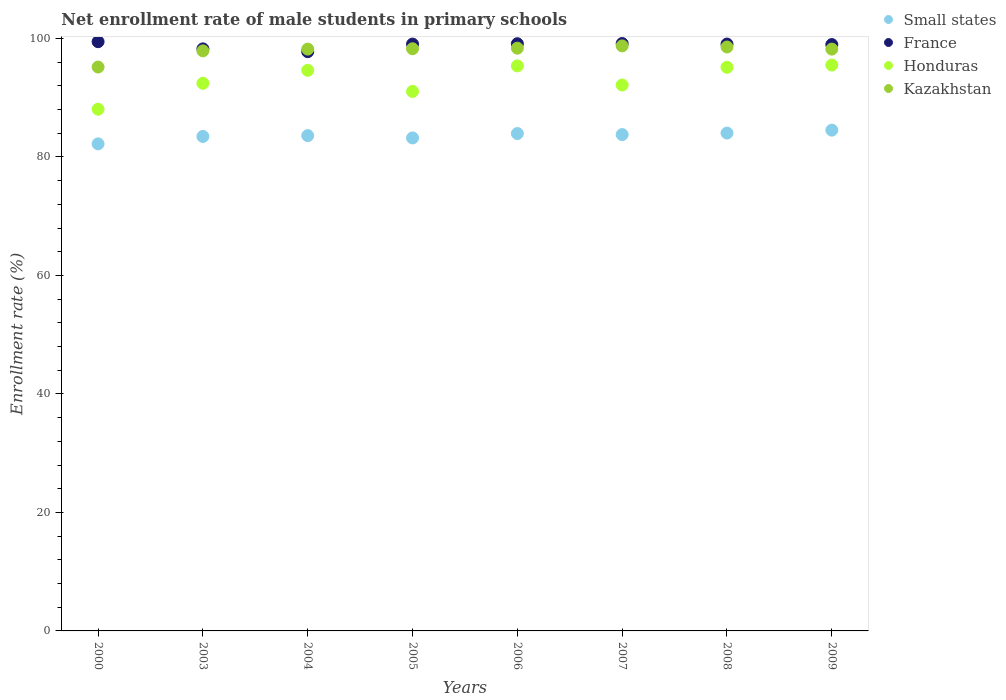Is the number of dotlines equal to the number of legend labels?
Provide a short and direct response. Yes. What is the net enrollment rate of male students in primary schools in Small states in 2008?
Your answer should be very brief. 84.03. Across all years, what is the maximum net enrollment rate of male students in primary schools in Kazakhstan?
Your answer should be compact. 98.74. Across all years, what is the minimum net enrollment rate of male students in primary schools in France?
Provide a short and direct response. 97.77. In which year was the net enrollment rate of male students in primary schools in Honduras maximum?
Make the answer very short. 2009. In which year was the net enrollment rate of male students in primary schools in Small states minimum?
Provide a succinct answer. 2000. What is the total net enrollment rate of male students in primary schools in France in the graph?
Your answer should be compact. 790.77. What is the difference between the net enrollment rate of male students in primary schools in Kazakhstan in 2000 and that in 2009?
Give a very brief answer. -3.03. What is the difference between the net enrollment rate of male students in primary schools in France in 2004 and the net enrollment rate of male students in primary schools in Kazakhstan in 2003?
Give a very brief answer. -0.14. What is the average net enrollment rate of male students in primary schools in Kazakhstan per year?
Provide a short and direct response. 97.92. In the year 2000, what is the difference between the net enrollment rate of male students in primary schools in Small states and net enrollment rate of male students in primary schools in Honduras?
Your response must be concise. -5.85. What is the ratio of the net enrollment rate of male students in primary schools in Small states in 2003 to that in 2006?
Keep it short and to the point. 0.99. Is the difference between the net enrollment rate of male students in primary schools in Small states in 2003 and 2006 greater than the difference between the net enrollment rate of male students in primary schools in Honduras in 2003 and 2006?
Ensure brevity in your answer.  Yes. What is the difference between the highest and the second highest net enrollment rate of male students in primary schools in Small states?
Provide a short and direct response. 0.49. What is the difference between the highest and the lowest net enrollment rate of male students in primary schools in Kazakhstan?
Your answer should be compact. 3.57. In how many years, is the net enrollment rate of male students in primary schools in Small states greater than the average net enrollment rate of male students in primary schools in Small states taken over all years?
Your answer should be very brief. 5. Is the sum of the net enrollment rate of male students in primary schools in Kazakhstan in 2004 and 2005 greater than the maximum net enrollment rate of male students in primary schools in Honduras across all years?
Give a very brief answer. Yes. Does the net enrollment rate of male students in primary schools in Kazakhstan monotonically increase over the years?
Ensure brevity in your answer.  No. Is the net enrollment rate of male students in primary schools in Small states strictly less than the net enrollment rate of male students in primary schools in Honduras over the years?
Provide a short and direct response. Yes. How many dotlines are there?
Keep it short and to the point. 4. How many years are there in the graph?
Make the answer very short. 8. What is the difference between two consecutive major ticks on the Y-axis?
Make the answer very short. 20. Are the values on the major ticks of Y-axis written in scientific E-notation?
Your response must be concise. No. Does the graph contain any zero values?
Your response must be concise. No. What is the title of the graph?
Your response must be concise. Net enrollment rate of male students in primary schools. Does "Kiribati" appear as one of the legend labels in the graph?
Provide a short and direct response. No. What is the label or title of the Y-axis?
Keep it short and to the point. Enrollment rate (%). What is the Enrollment rate (%) of Small states in 2000?
Offer a terse response. 82.21. What is the Enrollment rate (%) of France in 2000?
Offer a terse response. 99.45. What is the Enrollment rate (%) of Honduras in 2000?
Your answer should be very brief. 88.06. What is the Enrollment rate (%) of Kazakhstan in 2000?
Your answer should be compact. 95.17. What is the Enrollment rate (%) in Small states in 2003?
Your response must be concise. 83.46. What is the Enrollment rate (%) in France in 2003?
Offer a terse response. 98.24. What is the Enrollment rate (%) in Honduras in 2003?
Offer a terse response. 92.43. What is the Enrollment rate (%) of Kazakhstan in 2003?
Provide a short and direct response. 97.9. What is the Enrollment rate (%) in Small states in 2004?
Provide a succinct answer. 83.6. What is the Enrollment rate (%) of France in 2004?
Your response must be concise. 97.77. What is the Enrollment rate (%) in Honduras in 2004?
Offer a very short reply. 94.62. What is the Enrollment rate (%) of Kazakhstan in 2004?
Make the answer very short. 98.2. What is the Enrollment rate (%) of Small states in 2005?
Offer a terse response. 83.21. What is the Enrollment rate (%) in France in 2005?
Your response must be concise. 99.05. What is the Enrollment rate (%) of Honduras in 2005?
Give a very brief answer. 91.06. What is the Enrollment rate (%) of Kazakhstan in 2005?
Your answer should be compact. 98.26. What is the Enrollment rate (%) of Small states in 2006?
Your response must be concise. 83.95. What is the Enrollment rate (%) in France in 2006?
Provide a succinct answer. 99.11. What is the Enrollment rate (%) in Honduras in 2006?
Provide a short and direct response. 95.37. What is the Enrollment rate (%) of Kazakhstan in 2006?
Keep it short and to the point. 98.36. What is the Enrollment rate (%) of Small states in 2007?
Make the answer very short. 83.77. What is the Enrollment rate (%) of France in 2007?
Offer a very short reply. 99.14. What is the Enrollment rate (%) of Honduras in 2007?
Your response must be concise. 92.14. What is the Enrollment rate (%) of Kazakhstan in 2007?
Offer a very short reply. 98.74. What is the Enrollment rate (%) of Small states in 2008?
Make the answer very short. 84.03. What is the Enrollment rate (%) of France in 2008?
Your response must be concise. 99.05. What is the Enrollment rate (%) of Honduras in 2008?
Make the answer very short. 95.13. What is the Enrollment rate (%) in Kazakhstan in 2008?
Provide a succinct answer. 98.56. What is the Enrollment rate (%) of Small states in 2009?
Make the answer very short. 84.52. What is the Enrollment rate (%) of France in 2009?
Give a very brief answer. 98.97. What is the Enrollment rate (%) in Honduras in 2009?
Give a very brief answer. 95.51. What is the Enrollment rate (%) of Kazakhstan in 2009?
Offer a very short reply. 98.2. Across all years, what is the maximum Enrollment rate (%) of Small states?
Offer a very short reply. 84.52. Across all years, what is the maximum Enrollment rate (%) in France?
Keep it short and to the point. 99.45. Across all years, what is the maximum Enrollment rate (%) in Honduras?
Provide a short and direct response. 95.51. Across all years, what is the maximum Enrollment rate (%) of Kazakhstan?
Make the answer very short. 98.74. Across all years, what is the minimum Enrollment rate (%) of Small states?
Give a very brief answer. 82.21. Across all years, what is the minimum Enrollment rate (%) of France?
Offer a very short reply. 97.77. Across all years, what is the minimum Enrollment rate (%) in Honduras?
Provide a succinct answer. 88.06. Across all years, what is the minimum Enrollment rate (%) in Kazakhstan?
Make the answer very short. 95.17. What is the total Enrollment rate (%) of Small states in the graph?
Offer a terse response. 668.75. What is the total Enrollment rate (%) of France in the graph?
Make the answer very short. 790.77. What is the total Enrollment rate (%) in Honduras in the graph?
Make the answer very short. 744.32. What is the total Enrollment rate (%) of Kazakhstan in the graph?
Offer a terse response. 783.4. What is the difference between the Enrollment rate (%) of Small states in 2000 and that in 2003?
Give a very brief answer. -1.25. What is the difference between the Enrollment rate (%) in France in 2000 and that in 2003?
Your answer should be compact. 1.21. What is the difference between the Enrollment rate (%) in Honduras in 2000 and that in 2003?
Provide a succinct answer. -4.37. What is the difference between the Enrollment rate (%) of Kazakhstan in 2000 and that in 2003?
Give a very brief answer. -2.73. What is the difference between the Enrollment rate (%) of Small states in 2000 and that in 2004?
Provide a short and direct response. -1.39. What is the difference between the Enrollment rate (%) in France in 2000 and that in 2004?
Your answer should be very brief. 1.69. What is the difference between the Enrollment rate (%) in Honduras in 2000 and that in 2004?
Make the answer very short. -6.57. What is the difference between the Enrollment rate (%) of Kazakhstan in 2000 and that in 2004?
Offer a very short reply. -3.03. What is the difference between the Enrollment rate (%) of Small states in 2000 and that in 2005?
Your answer should be very brief. -1.01. What is the difference between the Enrollment rate (%) in France in 2000 and that in 2005?
Provide a succinct answer. 0.41. What is the difference between the Enrollment rate (%) of Honduras in 2000 and that in 2005?
Your response must be concise. -3. What is the difference between the Enrollment rate (%) of Kazakhstan in 2000 and that in 2005?
Give a very brief answer. -3.09. What is the difference between the Enrollment rate (%) in Small states in 2000 and that in 2006?
Offer a terse response. -1.75. What is the difference between the Enrollment rate (%) in France in 2000 and that in 2006?
Provide a succinct answer. 0.34. What is the difference between the Enrollment rate (%) in Honduras in 2000 and that in 2006?
Provide a short and direct response. -7.31. What is the difference between the Enrollment rate (%) in Kazakhstan in 2000 and that in 2006?
Your response must be concise. -3.19. What is the difference between the Enrollment rate (%) of Small states in 2000 and that in 2007?
Your answer should be compact. -1.57. What is the difference between the Enrollment rate (%) in France in 2000 and that in 2007?
Make the answer very short. 0.31. What is the difference between the Enrollment rate (%) of Honduras in 2000 and that in 2007?
Your answer should be very brief. -4.08. What is the difference between the Enrollment rate (%) of Kazakhstan in 2000 and that in 2007?
Make the answer very short. -3.57. What is the difference between the Enrollment rate (%) in Small states in 2000 and that in 2008?
Keep it short and to the point. -1.82. What is the difference between the Enrollment rate (%) in France in 2000 and that in 2008?
Ensure brevity in your answer.  0.4. What is the difference between the Enrollment rate (%) of Honduras in 2000 and that in 2008?
Your answer should be compact. -7.07. What is the difference between the Enrollment rate (%) in Kazakhstan in 2000 and that in 2008?
Your response must be concise. -3.39. What is the difference between the Enrollment rate (%) in Small states in 2000 and that in 2009?
Provide a succinct answer. -2.32. What is the difference between the Enrollment rate (%) of France in 2000 and that in 2009?
Ensure brevity in your answer.  0.49. What is the difference between the Enrollment rate (%) of Honduras in 2000 and that in 2009?
Your answer should be compact. -7.45. What is the difference between the Enrollment rate (%) of Kazakhstan in 2000 and that in 2009?
Your answer should be very brief. -3.03. What is the difference between the Enrollment rate (%) in Small states in 2003 and that in 2004?
Ensure brevity in your answer.  -0.14. What is the difference between the Enrollment rate (%) of France in 2003 and that in 2004?
Provide a short and direct response. 0.48. What is the difference between the Enrollment rate (%) of Honduras in 2003 and that in 2004?
Keep it short and to the point. -2.19. What is the difference between the Enrollment rate (%) of Kazakhstan in 2003 and that in 2004?
Your answer should be compact. -0.3. What is the difference between the Enrollment rate (%) of Small states in 2003 and that in 2005?
Provide a succinct answer. 0.25. What is the difference between the Enrollment rate (%) in France in 2003 and that in 2005?
Give a very brief answer. -0.8. What is the difference between the Enrollment rate (%) in Honduras in 2003 and that in 2005?
Offer a very short reply. 1.37. What is the difference between the Enrollment rate (%) in Kazakhstan in 2003 and that in 2005?
Provide a succinct answer. -0.36. What is the difference between the Enrollment rate (%) of Small states in 2003 and that in 2006?
Keep it short and to the point. -0.49. What is the difference between the Enrollment rate (%) in France in 2003 and that in 2006?
Ensure brevity in your answer.  -0.87. What is the difference between the Enrollment rate (%) of Honduras in 2003 and that in 2006?
Offer a very short reply. -2.94. What is the difference between the Enrollment rate (%) in Kazakhstan in 2003 and that in 2006?
Give a very brief answer. -0.45. What is the difference between the Enrollment rate (%) of Small states in 2003 and that in 2007?
Provide a short and direct response. -0.32. What is the difference between the Enrollment rate (%) of France in 2003 and that in 2007?
Your response must be concise. -0.9. What is the difference between the Enrollment rate (%) in Honduras in 2003 and that in 2007?
Keep it short and to the point. 0.29. What is the difference between the Enrollment rate (%) of Kazakhstan in 2003 and that in 2007?
Offer a terse response. -0.84. What is the difference between the Enrollment rate (%) in Small states in 2003 and that in 2008?
Your answer should be very brief. -0.57. What is the difference between the Enrollment rate (%) in France in 2003 and that in 2008?
Offer a terse response. -0.81. What is the difference between the Enrollment rate (%) of Honduras in 2003 and that in 2008?
Offer a very short reply. -2.7. What is the difference between the Enrollment rate (%) in Kazakhstan in 2003 and that in 2008?
Offer a very short reply. -0.65. What is the difference between the Enrollment rate (%) in Small states in 2003 and that in 2009?
Offer a very short reply. -1.06. What is the difference between the Enrollment rate (%) in France in 2003 and that in 2009?
Provide a short and direct response. -0.73. What is the difference between the Enrollment rate (%) in Honduras in 2003 and that in 2009?
Make the answer very short. -3.08. What is the difference between the Enrollment rate (%) in Kazakhstan in 2003 and that in 2009?
Give a very brief answer. -0.29. What is the difference between the Enrollment rate (%) of Small states in 2004 and that in 2005?
Offer a very short reply. 0.39. What is the difference between the Enrollment rate (%) in France in 2004 and that in 2005?
Your answer should be compact. -1.28. What is the difference between the Enrollment rate (%) in Honduras in 2004 and that in 2005?
Ensure brevity in your answer.  3.56. What is the difference between the Enrollment rate (%) of Kazakhstan in 2004 and that in 2005?
Offer a terse response. -0.06. What is the difference between the Enrollment rate (%) of Small states in 2004 and that in 2006?
Your answer should be compact. -0.35. What is the difference between the Enrollment rate (%) in France in 2004 and that in 2006?
Your response must be concise. -1.34. What is the difference between the Enrollment rate (%) of Honduras in 2004 and that in 2006?
Keep it short and to the point. -0.74. What is the difference between the Enrollment rate (%) in Kazakhstan in 2004 and that in 2006?
Provide a succinct answer. -0.16. What is the difference between the Enrollment rate (%) in Small states in 2004 and that in 2007?
Provide a succinct answer. -0.17. What is the difference between the Enrollment rate (%) of France in 2004 and that in 2007?
Your answer should be compact. -1.37. What is the difference between the Enrollment rate (%) of Honduras in 2004 and that in 2007?
Your response must be concise. 2.48. What is the difference between the Enrollment rate (%) of Kazakhstan in 2004 and that in 2007?
Make the answer very short. -0.54. What is the difference between the Enrollment rate (%) in Small states in 2004 and that in 2008?
Give a very brief answer. -0.43. What is the difference between the Enrollment rate (%) in France in 2004 and that in 2008?
Offer a terse response. -1.28. What is the difference between the Enrollment rate (%) of Honduras in 2004 and that in 2008?
Your answer should be compact. -0.51. What is the difference between the Enrollment rate (%) in Kazakhstan in 2004 and that in 2008?
Give a very brief answer. -0.36. What is the difference between the Enrollment rate (%) of Small states in 2004 and that in 2009?
Make the answer very short. -0.92. What is the difference between the Enrollment rate (%) in France in 2004 and that in 2009?
Your answer should be very brief. -1.2. What is the difference between the Enrollment rate (%) of Honduras in 2004 and that in 2009?
Offer a terse response. -0.89. What is the difference between the Enrollment rate (%) of Kazakhstan in 2004 and that in 2009?
Keep it short and to the point. 0. What is the difference between the Enrollment rate (%) of Small states in 2005 and that in 2006?
Offer a terse response. -0.74. What is the difference between the Enrollment rate (%) of France in 2005 and that in 2006?
Provide a succinct answer. -0.06. What is the difference between the Enrollment rate (%) in Honduras in 2005 and that in 2006?
Offer a very short reply. -4.31. What is the difference between the Enrollment rate (%) in Kazakhstan in 2005 and that in 2006?
Your answer should be compact. -0.1. What is the difference between the Enrollment rate (%) in Small states in 2005 and that in 2007?
Offer a terse response. -0.56. What is the difference between the Enrollment rate (%) in France in 2005 and that in 2007?
Provide a succinct answer. -0.09. What is the difference between the Enrollment rate (%) of Honduras in 2005 and that in 2007?
Your response must be concise. -1.08. What is the difference between the Enrollment rate (%) of Kazakhstan in 2005 and that in 2007?
Keep it short and to the point. -0.48. What is the difference between the Enrollment rate (%) of Small states in 2005 and that in 2008?
Offer a very short reply. -0.82. What is the difference between the Enrollment rate (%) in France in 2005 and that in 2008?
Offer a very short reply. -0. What is the difference between the Enrollment rate (%) in Honduras in 2005 and that in 2008?
Offer a terse response. -4.07. What is the difference between the Enrollment rate (%) in Kazakhstan in 2005 and that in 2008?
Ensure brevity in your answer.  -0.3. What is the difference between the Enrollment rate (%) of Small states in 2005 and that in 2009?
Give a very brief answer. -1.31. What is the difference between the Enrollment rate (%) in France in 2005 and that in 2009?
Ensure brevity in your answer.  0.08. What is the difference between the Enrollment rate (%) of Honduras in 2005 and that in 2009?
Keep it short and to the point. -4.45. What is the difference between the Enrollment rate (%) in Kazakhstan in 2005 and that in 2009?
Offer a terse response. 0.06. What is the difference between the Enrollment rate (%) in Small states in 2006 and that in 2007?
Your answer should be very brief. 0.18. What is the difference between the Enrollment rate (%) of France in 2006 and that in 2007?
Provide a short and direct response. -0.03. What is the difference between the Enrollment rate (%) of Honduras in 2006 and that in 2007?
Provide a succinct answer. 3.22. What is the difference between the Enrollment rate (%) of Kazakhstan in 2006 and that in 2007?
Your answer should be compact. -0.38. What is the difference between the Enrollment rate (%) of Small states in 2006 and that in 2008?
Keep it short and to the point. -0.08. What is the difference between the Enrollment rate (%) of France in 2006 and that in 2008?
Offer a terse response. 0.06. What is the difference between the Enrollment rate (%) in Honduras in 2006 and that in 2008?
Make the answer very short. 0.24. What is the difference between the Enrollment rate (%) in Kazakhstan in 2006 and that in 2008?
Make the answer very short. -0.2. What is the difference between the Enrollment rate (%) in Small states in 2006 and that in 2009?
Your answer should be compact. -0.57. What is the difference between the Enrollment rate (%) in France in 2006 and that in 2009?
Offer a very short reply. 0.14. What is the difference between the Enrollment rate (%) of Honduras in 2006 and that in 2009?
Your answer should be compact. -0.15. What is the difference between the Enrollment rate (%) of Kazakhstan in 2006 and that in 2009?
Provide a short and direct response. 0.16. What is the difference between the Enrollment rate (%) of Small states in 2007 and that in 2008?
Your response must be concise. -0.25. What is the difference between the Enrollment rate (%) of France in 2007 and that in 2008?
Give a very brief answer. 0.09. What is the difference between the Enrollment rate (%) in Honduras in 2007 and that in 2008?
Your answer should be compact. -2.99. What is the difference between the Enrollment rate (%) of Kazakhstan in 2007 and that in 2008?
Offer a very short reply. 0.19. What is the difference between the Enrollment rate (%) in Small states in 2007 and that in 2009?
Offer a very short reply. -0.75. What is the difference between the Enrollment rate (%) of France in 2007 and that in 2009?
Your response must be concise. 0.17. What is the difference between the Enrollment rate (%) of Honduras in 2007 and that in 2009?
Your response must be concise. -3.37. What is the difference between the Enrollment rate (%) of Kazakhstan in 2007 and that in 2009?
Ensure brevity in your answer.  0.54. What is the difference between the Enrollment rate (%) of Small states in 2008 and that in 2009?
Your response must be concise. -0.49. What is the difference between the Enrollment rate (%) in France in 2008 and that in 2009?
Your answer should be compact. 0.08. What is the difference between the Enrollment rate (%) in Honduras in 2008 and that in 2009?
Your answer should be compact. -0.38. What is the difference between the Enrollment rate (%) in Kazakhstan in 2008 and that in 2009?
Your answer should be compact. 0.36. What is the difference between the Enrollment rate (%) in Small states in 2000 and the Enrollment rate (%) in France in 2003?
Your answer should be compact. -16.04. What is the difference between the Enrollment rate (%) of Small states in 2000 and the Enrollment rate (%) of Honduras in 2003?
Provide a short and direct response. -10.22. What is the difference between the Enrollment rate (%) of Small states in 2000 and the Enrollment rate (%) of Kazakhstan in 2003?
Offer a terse response. -15.7. What is the difference between the Enrollment rate (%) in France in 2000 and the Enrollment rate (%) in Honduras in 2003?
Ensure brevity in your answer.  7.03. What is the difference between the Enrollment rate (%) of France in 2000 and the Enrollment rate (%) of Kazakhstan in 2003?
Ensure brevity in your answer.  1.55. What is the difference between the Enrollment rate (%) of Honduras in 2000 and the Enrollment rate (%) of Kazakhstan in 2003?
Provide a short and direct response. -9.85. What is the difference between the Enrollment rate (%) of Small states in 2000 and the Enrollment rate (%) of France in 2004?
Make the answer very short. -15.56. What is the difference between the Enrollment rate (%) in Small states in 2000 and the Enrollment rate (%) in Honduras in 2004?
Make the answer very short. -12.42. What is the difference between the Enrollment rate (%) of Small states in 2000 and the Enrollment rate (%) of Kazakhstan in 2004?
Offer a very short reply. -16. What is the difference between the Enrollment rate (%) of France in 2000 and the Enrollment rate (%) of Honduras in 2004?
Your answer should be compact. 4.83. What is the difference between the Enrollment rate (%) in France in 2000 and the Enrollment rate (%) in Kazakhstan in 2004?
Your response must be concise. 1.25. What is the difference between the Enrollment rate (%) of Honduras in 2000 and the Enrollment rate (%) of Kazakhstan in 2004?
Make the answer very short. -10.14. What is the difference between the Enrollment rate (%) in Small states in 2000 and the Enrollment rate (%) in France in 2005?
Offer a very short reply. -16.84. What is the difference between the Enrollment rate (%) in Small states in 2000 and the Enrollment rate (%) in Honduras in 2005?
Provide a succinct answer. -8.85. What is the difference between the Enrollment rate (%) in Small states in 2000 and the Enrollment rate (%) in Kazakhstan in 2005?
Give a very brief answer. -16.06. What is the difference between the Enrollment rate (%) in France in 2000 and the Enrollment rate (%) in Honduras in 2005?
Your answer should be very brief. 8.39. What is the difference between the Enrollment rate (%) of France in 2000 and the Enrollment rate (%) of Kazakhstan in 2005?
Make the answer very short. 1.19. What is the difference between the Enrollment rate (%) of Honduras in 2000 and the Enrollment rate (%) of Kazakhstan in 2005?
Offer a very short reply. -10.2. What is the difference between the Enrollment rate (%) of Small states in 2000 and the Enrollment rate (%) of France in 2006?
Your response must be concise. -16.9. What is the difference between the Enrollment rate (%) of Small states in 2000 and the Enrollment rate (%) of Honduras in 2006?
Offer a terse response. -13.16. What is the difference between the Enrollment rate (%) in Small states in 2000 and the Enrollment rate (%) in Kazakhstan in 2006?
Give a very brief answer. -16.15. What is the difference between the Enrollment rate (%) in France in 2000 and the Enrollment rate (%) in Honduras in 2006?
Provide a succinct answer. 4.09. What is the difference between the Enrollment rate (%) of France in 2000 and the Enrollment rate (%) of Kazakhstan in 2006?
Make the answer very short. 1.09. What is the difference between the Enrollment rate (%) of Honduras in 2000 and the Enrollment rate (%) of Kazakhstan in 2006?
Your response must be concise. -10.3. What is the difference between the Enrollment rate (%) in Small states in 2000 and the Enrollment rate (%) in France in 2007?
Make the answer very short. -16.93. What is the difference between the Enrollment rate (%) in Small states in 2000 and the Enrollment rate (%) in Honduras in 2007?
Give a very brief answer. -9.94. What is the difference between the Enrollment rate (%) in Small states in 2000 and the Enrollment rate (%) in Kazakhstan in 2007?
Provide a succinct answer. -16.54. What is the difference between the Enrollment rate (%) of France in 2000 and the Enrollment rate (%) of Honduras in 2007?
Give a very brief answer. 7.31. What is the difference between the Enrollment rate (%) in France in 2000 and the Enrollment rate (%) in Kazakhstan in 2007?
Offer a terse response. 0.71. What is the difference between the Enrollment rate (%) in Honduras in 2000 and the Enrollment rate (%) in Kazakhstan in 2007?
Offer a terse response. -10.69. What is the difference between the Enrollment rate (%) in Small states in 2000 and the Enrollment rate (%) in France in 2008?
Offer a terse response. -16.85. What is the difference between the Enrollment rate (%) of Small states in 2000 and the Enrollment rate (%) of Honduras in 2008?
Give a very brief answer. -12.93. What is the difference between the Enrollment rate (%) of Small states in 2000 and the Enrollment rate (%) of Kazakhstan in 2008?
Provide a succinct answer. -16.35. What is the difference between the Enrollment rate (%) in France in 2000 and the Enrollment rate (%) in Honduras in 2008?
Provide a short and direct response. 4.32. What is the difference between the Enrollment rate (%) of France in 2000 and the Enrollment rate (%) of Kazakhstan in 2008?
Provide a short and direct response. 0.9. What is the difference between the Enrollment rate (%) in Honduras in 2000 and the Enrollment rate (%) in Kazakhstan in 2008?
Make the answer very short. -10.5. What is the difference between the Enrollment rate (%) in Small states in 2000 and the Enrollment rate (%) in France in 2009?
Your response must be concise. -16.76. What is the difference between the Enrollment rate (%) in Small states in 2000 and the Enrollment rate (%) in Honduras in 2009?
Your answer should be very brief. -13.31. What is the difference between the Enrollment rate (%) in Small states in 2000 and the Enrollment rate (%) in Kazakhstan in 2009?
Provide a succinct answer. -15.99. What is the difference between the Enrollment rate (%) of France in 2000 and the Enrollment rate (%) of Honduras in 2009?
Make the answer very short. 3.94. What is the difference between the Enrollment rate (%) in France in 2000 and the Enrollment rate (%) in Kazakhstan in 2009?
Your response must be concise. 1.25. What is the difference between the Enrollment rate (%) of Honduras in 2000 and the Enrollment rate (%) of Kazakhstan in 2009?
Give a very brief answer. -10.14. What is the difference between the Enrollment rate (%) of Small states in 2003 and the Enrollment rate (%) of France in 2004?
Provide a short and direct response. -14.31. What is the difference between the Enrollment rate (%) of Small states in 2003 and the Enrollment rate (%) of Honduras in 2004?
Offer a very short reply. -11.16. What is the difference between the Enrollment rate (%) of Small states in 2003 and the Enrollment rate (%) of Kazakhstan in 2004?
Your response must be concise. -14.74. What is the difference between the Enrollment rate (%) of France in 2003 and the Enrollment rate (%) of Honduras in 2004?
Offer a very short reply. 3.62. What is the difference between the Enrollment rate (%) of France in 2003 and the Enrollment rate (%) of Kazakhstan in 2004?
Offer a very short reply. 0.04. What is the difference between the Enrollment rate (%) in Honduras in 2003 and the Enrollment rate (%) in Kazakhstan in 2004?
Offer a very short reply. -5.77. What is the difference between the Enrollment rate (%) in Small states in 2003 and the Enrollment rate (%) in France in 2005?
Offer a very short reply. -15.59. What is the difference between the Enrollment rate (%) in Small states in 2003 and the Enrollment rate (%) in Honduras in 2005?
Provide a succinct answer. -7.6. What is the difference between the Enrollment rate (%) in Small states in 2003 and the Enrollment rate (%) in Kazakhstan in 2005?
Give a very brief answer. -14.8. What is the difference between the Enrollment rate (%) in France in 2003 and the Enrollment rate (%) in Honduras in 2005?
Offer a very short reply. 7.18. What is the difference between the Enrollment rate (%) of France in 2003 and the Enrollment rate (%) of Kazakhstan in 2005?
Keep it short and to the point. -0.02. What is the difference between the Enrollment rate (%) in Honduras in 2003 and the Enrollment rate (%) in Kazakhstan in 2005?
Give a very brief answer. -5.83. What is the difference between the Enrollment rate (%) of Small states in 2003 and the Enrollment rate (%) of France in 2006?
Your response must be concise. -15.65. What is the difference between the Enrollment rate (%) in Small states in 2003 and the Enrollment rate (%) in Honduras in 2006?
Offer a terse response. -11.91. What is the difference between the Enrollment rate (%) of Small states in 2003 and the Enrollment rate (%) of Kazakhstan in 2006?
Your response must be concise. -14.9. What is the difference between the Enrollment rate (%) in France in 2003 and the Enrollment rate (%) in Honduras in 2006?
Provide a short and direct response. 2.88. What is the difference between the Enrollment rate (%) of France in 2003 and the Enrollment rate (%) of Kazakhstan in 2006?
Offer a terse response. -0.12. What is the difference between the Enrollment rate (%) of Honduras in 2003 and the Enrollment rate (%) of Kazakhstan in 2006?
Offer a very short reply. -5.93. What is the difference between the Enrollment rate (%) in Small states in 2003 and the Enrollment rate (%) in France in 2007?
Keep it short and to the point. -15.68. What is the difference between the Enrollment rate (%) of Small states in 2003 and the Enrollment rate (%) of Honduras in 2007?
Make the answer very short. -8.68. What is the difference between the Enrollment rate (%) in Small states in 2003 and the Enrollment rate (%) in Kazakhstan in 2007?
Keep it short and to the point. -15.28. What is the difference between the Enrollment rate (%) of France in 2003 and the Enrollment rate (%) of Honduras in 2007?
Your response must be concise. 6.1. What is the difference between the Enrollment rate (%) of France in 2003 and the Enrollment rate (%) of Kazakhstan in 2007?
Your response must be concise. -0.5. What is the difference between the Enrollment rate (%) in Honduras in 2003 and the Enrollment rate (%) in Kazakhstan in 2007?
Your answer should be very brief. -6.32. What is the difference between the Enrollment rate (%) in Small states in 2003 and the Enrollment rate (%) in France in 2008?
Provide a succinct answer. -15.59. What is the difference between the Enrollment rate (%) in Small states in 2003 and the Enrollment rate (%) in Honduras in 2008?
Offer a terse response. -11.67. What is the difference between the Enrollment rate (%) in Small states in 2003 and the Enrollment rate (%) in Kazakhstan in 2008?
Ensure brevity in your answer.  -15.1. What is the difference between the Enrollment rate (%) of France in 2003 and the Enrollment rate (%) of Honduras in 2008?
Your answer should be compact. 3.11. What is the difference between the Enrollment rate (%) of France in 2003 and the Enrollment rate (%) of Kazakhstan in 2008?
Provide a succinct answer. -0.32. What is the difference between the Enrollment rate (%) of Honduras in 2003 and the Enrollment rate (%) of Kazakhstan in 2008?
Provide a succinct answer. -6.13. What is the difference between the Enrollment rate (%) of Small states in 2003 and the Enrollment rate (%) of France in 2009?
Offer a very short reply. -15.51. What is the difference between the Enrollment rate (%) in Small states in 2003 and the Enrollment rate (%) in Honduras in 2009?
Provide a short and direct response. -12.05. What is the difference between the Enrollment rate (%) of Small states in 2003 and the Enrollment rate (%) of Kazakhstan in 2009?
Provide a succinct answer. -14.74. What is the difference between the Enrollment rate (%) in France in 2003 and the Enrollment rate (%) in Honduras in 2009?
Offer a terse response. 2.73. What is the difference between the Enrollment rate (%) of France in 2003 and the Enrollment rate (%) of Kazakhstan in 2009?
Give a very brief answer. 0.04. What is the difference between the Enrollment rate (%) of Honduras in 2003 and the Enrollment rate (%) of Kazakhstan in 2009?
Ensure brevity in your answer.  -5.77. What is the difference between the Enrollment rate (%) in Small states in 2004 and the Enrollment rate (%) in France in 2005?
Make the answer very short. -15.45. What is the difference between the Enrollment rate (%) in Small states in 2004 and the Enrollment rate (%) in Honduras in 2005?
Give a very brief answer. -7.46. What is the difference between the Enrollment rate (%) of Small states in 2004 and the Enrollment rate (%) of Kazakhstan in 2005?
Provide a short and direct response. -14.66. What is the difference between the Enrollment rate (%) of France in 2004 and the Enrollment rate (%) of Honduras in 2005?
Keep it short and to the point. 6.71. What is the difference between the Enrollment rate (%) of France in 2004 and the Enrollment rate (%) of Kazakhstan in 2005?
Keep it short and to the point. -0.5. What is the difference between the Enrollment rate (%) of Honduras in 2004 and the Enrollment rate (%) of Kazakhstan in 2005?
Ensure brevity in your answer.  -3.64. What is the difference between the Enrollment rate (%) in Small states in 2004 and the Enrollment rate (%) in France in 2006?
Your response must be concise. -15.51. What is the difference between the Enrollment rate (%) in Small states in 2004 and the Enrollment rate (%) in Honduras in 2006?
Offer a terse response. -11.77. What is the difference between the Enrollment rate (%) in Small states in 2004 and the Enrollment rate (%) in Kazakhstan in 2006?
Provide a short and direct response. -14.76. What is the difference between the Enrollment rate (%) of France in 2004 and the Enrollment rate (%) of Honduras in 2006?
Keep it short and to the point. 2.4. What is the difference between the Enrollment rate (%) in France in 2004 and the Enrollment rate (%) in Kazakhstan in 2006?
Ensure brevity in your answer.  -0.59. What is the difference between the Enrollment rate (%) of Honduras in 2004 and the Enrollment rate (%) of Kazakhstan in 2006?
Your response must be concise. -3.74. What is the difference between the Enrollment rate (%) in Small states in 2004 and the Enrollment rate (%) in France in 2007?
Ensure brevity in your answer.  -15.54. What is the difference between the Enrollment rate (%) in Small states in 2004 and the Enrollment rate (%) in Honduras in 2007?
Offer a very short reply. -8.54. What is the difference between the Enrollment rate (%) of Small states in 2004 and the Enrollment rate (%) of Kazakhstan in 2007?
Offer a terse response. -15.14. What is the difference between the Enrollment rate (%) in France in 2004 and the Enrollment rate (%) in Honduras in 2007?
Ensure brevity in your answer.  5.62. What is the difference between the Enrollment rate (%) in France in 2004 and the Enrollment rate (%) in Kazakhstan in 2007?
Your answer should be compact. -0.98. What is the difference between the Enrollment rate (%) in Honduras in 2004 and the Enrollment rate (%) in Kazakhstan in 2007?
Make the answer very short. -4.12. What is the difference between the Enrollment rate (%) of Small states in 2004 and the Enrollment rate (%) of France in 2008?
Your answer should be very brief. -15.45. What is the difference between the Enrollment rate (%) in Small states in 2004 and the Enrollment rate (%) in Honduras in 2008?
Give a very brief answer. -11.53. What is the difference between the Enrollment rate (%) in Small states in 2004 and the Enrollment rate (%) in Kazakhstan in 2008?
Give a very brief answer. -14.96. What is the difference between the Enrollment rate (%) of France in 2004 and the Enrollment rate (%) of Honduras in 2008?
Your response must be concise. 2.64. What is the difference between the Enrollment rate (%) in France in 2004 and the Enrollment rate (%) in Kazakhstan in 2008?
Provide a short and direct response. -0.79. What is the difference between the Enrollment rate (%) in Honduras in 2004 and the Enrollment rate (%) in Kazakhstan in 2008?
Your answer should be compact. -3.94. What is the difference between the Enrollment rate (%) of Small states in 2004 and the Enrollment rate (%) of France in 2009?
Make the answer very short. -15.37. What is the difference between the Enrollment rate (%) of Small states in 2004 and the Enrollment rate (%) of Honduras in 2009?
Offer a very short reply. -11.91. What is the difference between the Enrollment rate (%) of Small states in 2004 and the Enrollment rate (%) of Kazakhstan in 2009?
Keep it short and to the point. -14.6. What is the difference between the Enrollment rate (%) of France in 2004 and the Enrollment rate (%) of Honduras in 2009?
Provide a succinct answer. 2.25. What is the difference between the Enrollment rate (%) of France in 2004 and the Enrollment rate (%) of Kazakhstan in 2009?
Make the answer very short. -0.43. What is the difference between the Enrollment rate (%) in Honduras in 2004 and the Enrollment rate (%) in Kazakhstan in 2009?
Provide a succinct answer. -3.58. What is the difference between the Enrollment rate (%) in Small states in 2005 and the Enrollment rate (%) in France in 2006?
Keep it short and to the point. -15.9. What is the difference between the Enrollment rate (%) in Small states in 2005 and the Enrollment rate (%) in Honduras in 2006?
Make the answer very short. -12.15. What is the difference between the Enrollment rate (%) in Small states in 2005 and the Enrollment rate (%) in Kazakhstan in 2006?
Offer a very short reply. -15.15. What is the difference between the Enrollment rate (%) of France in 2005 and the Enrollment rate (%) of Honduras in 2006?
Ensure brevity in your answer.  3.68. What is the difference between the Enrollment rate (%) in France in 2005 and the Enrollment rate (%) in Kazakhstan in 2006?
Offer a terse response. 0.69. What is the difference between the Enrollment rate (%) of Honduras in 2005 and the Enrollment rate (%) of Kazakhstan in 2006?
Ensure brevity in your answer.  -7.3. What is the difference between the Enrollment rate (%) in Small states in 2005 and the Enrollment rate (%) in France in 2007?
Keep it short and to the point. -15.93. What is the difference between the Enrollment rate (%) of Small states in 2005 and the Enrollment rate (%) of Honduras in 2007?
Offer a very short reply. -8.93. What is the difference between the Enrollment rate (%) of Small states in 2005 and the Enrollment rate (%) of Kazakhstan in 2007?
Give a very brief answer. -15.53. What is the difference between the Enrollment rate (%) in France in 2005 and the Enrollment rate (%) in Honduras in 2007?
Your answer should be compact. 6.9. What is the difference between the Enrollment rate (%) in France in 2005 and the Enrollment rate (%) in Kazakhstan in 2007?
Provide a short and direct response. 0.3. What is the difference between the Enrollment rate (%) of Honduras in 2005 and the Enrollment rate (%) of Kazakhstan in 2007?
Offer a very short reply. -7.68. What is the difference between the Enrollment rate (%) in Small states in 2005 and the Enrollment rate (%) in France in 2008?
Offer a terse response. -15.84. What is the difference between the Enrollment rate (%) in Small states in 2005 and the Enrollment rate (%) in Honduras in 2008?
Keep it short and to the point. -11.92. What is the difference between the Enrollment rate (%) in Small states in 2005 and the Enrollment rate (%) in Kazakhstan in 2008?
Offer a very short reply. -15.35. What is the difference between the Enrollment rate (%) in France in 2005 and the Enrollment rate (%) in Honduras in 2008?
Make the answer very short. 3.92. What is the difference between the Enrollment rate (%) in France in 2005 and the Enrollment rate (%) in Kazakhstan in 2008?
Provide a short and direct response. 0.49. What is the difference between the Enrollment rate (%) in Honduras in 2005 and the Enrollment rate (%) in Kazakhstan in 2008?
Keep it short and to the point. -7.5. What is the difference between the Enrollment rate (%) in Small states in 2005 and the Enrollment rate (%) in France in 2009?
Offer a terse response. -15.76. What is the difference between the Enrollment rate (%) in Small states in 2005 and the Enrollment rate (%) in Honduras in 2009?
Make the answer very short. -12.3. What is the difference between the Enrollment rate (%) of Small states in 2005 and the Enrollment rate (%) of Kazakhstan in 2009?
Keep it short and to the point. -14.99. What is the difference between the Enrollment rate (%) in France in 2005 and the Enrollment rate (%) in Honduras in 2009?
Ensure brevity in your answer.  3.53. What is the difference between the Enrollment rate (%) in France in 2005 and the Enrollment rate (%) in Kazakhstan in 2009?
Your answer should be compact. 0.85. What is the difference between the Enrollment rate (%) of Honduras in 2005 and the Enrollment rate (%) of Kazakhstan in 2009?
Ensure brevity in your answer.  -7.14. What is the difference between the Enrollment rate (%) in Small states in 2006 and the Enrollment rate (%) in France in 2007?
Make the answer very short. -15.19. What is the difference between the Enrollment rate (%) of Small states in 2006 and the Enrollment rate (%) of Honduras in 2007?
Your answer should be very brief. -8.19. What is the difference between the Enrollment rate (%) in Small states in 2006 and the Enrollment rate (%) in Kazakhstan in 2007?
Offer a terse response. -14.79. What is the difference between the Enrollment rate (%) in France in 2006 and the Enrollment rate (%) in Honduras in 2007?
Your answer should be very brief. 6.97. What is the difference between the Enrollment rate (%) of France in 2006 and the Enrollment rate (%) of Kazakhstan in 2007?
Give a very brief answer. 0.37. What is the difference between the Enrollment rate (%) of Honduras in 2006 and the Enrollment rate (%) of Kazakhstan in 2007?
Your answer should be very brief. -3.38. What is the difference between the Enrollment rate (%) of Small states in 2006 and the Enrollment rate (%) of France in 2008?
Your answer should be compact. -15.1. What is the difference between the Enrollment rate (%) of Small states in 2006 and the Enrollment rate (%) of Honduras in 2008?
Ensure brevity in your answer.  -11.18. What is the difference between the Enrollment rate (%) in Small states in 2006 and the Enrollment rate (%) in Kazakhstan in 2008?
Ensure brevity in your answer.  -14.61. What is the difference between the Enrollment rate (%) in France in 2006 and the Enrollment rate (%) in Honduras in 2008?
Your response must be concise. 3.98. What is the difference between the Enrollment rate (%) of France in 2006 and the Enrollment rate (%) of Kazakhstan in 2008?
Offer a terse response. 0.55. What is the difference between the Enrollment rate (%) of Honduras in 2006 and the Enrollment rate (%) of Kazakhstan in 2008?
Provide a short and direct response. -3.19. What is the difference between the Enrollment rate (%) in Small states in 2006 and the Enrollment rate (%) in France in 2009?
Ensure brevity in your answer.  -15.02. What is the difference between the Enrollment rate (%) in Small states in 2006 and the Enrollment rate (%) in Honduras in 2009?
Provide a short and direct response. -11.56. What is the difference between the Enrollment rate (%) in Small states in 2006 and the Enrollment rate (%) in Kazakhstan in 2009?
Ensure brevity in your answer.  -14.25. What is the difference between the Enrollment rate (%) in France in 2006 and the Enrollment rate (%) in Honduras in 2009?
Make the answer very short. 3.6. What is the difference between the Enrollment rate (%) of Honduras in 2006 and the Enrollment rate (%) of Kazakhstan in 2009?
Your answer should be very brief. -2.83. What is the difference between the Enrollment rate (%) in Small states in 2007 and the Enrollment rate (%) in France in 2008?
Offer a terse response. -15.28. What is the difference between the Enrollment rate (%) in Small states in 2007 and the Enrollment rate (%) in Honduras in 2008?
Offer a very short reply. -11.36. What is the difference between the Enrollment rate (%) of Small states in 2007 and the Enrollment rate (%) of Kazakhstan in 2008?
Provide a short and direct response. -14.78. What is the difference between the Enrollment rate (%) in France in 2007 and the Enrollment rate (%) in Honduras in 2008?
Offer a very short reply. 4.01. What is the difference between the Enrollment rate (%) of France in 2007 and the Enrollment rate (%) of Kazakhstan in 2008?
Your answer should be very brief. 0.58. What is the difference between the Enrollment rate (%) in Honduras in 2007 and the Enrollment rate (%) in Kazakhstan in 2008?
Your answer should be compact. -6.42. What is the difference between the Enrollment rate (%) in Small states in 2007 and the Enrollment rate (%) in France in 2009?
Your response must be concise. -15.19. What is the difference between the Enrollment rate (%) of Small states in 2007 and the Enrollment rate (%) of Honduras in 2009?
Provide a succinct answer. -11.74. What is the difference between the Enrollment rate (%) of Small states in 2007 and the Enrollment rate (%) of Kazakhstan in 2009?
Ensure brevity in your answer.  -14.43. What is the difference between the Enrollment rate (%) in France in 2007 and the Enrollment rate (%) in Honduras in 2009?
Keep it short and to the point. 3.63. What is the difference between the Enrollment rate (%) of France in 2007 and the Enrollment rate (%) of Kazakhstan in 2009?
Provide a succinct answer. 0.94. What is the difference between the Enrollment rate (%) in Honduras in 2007 and the Enrollment rate (%) in Kazakhstan in 2009?
Keep it short and to the point. -6.06. What is the difference between the Enrollment rate (%) of Small states in 2008 and the Enrollment rate (%) of France in 2009?
Keep it short and to the point. -14.94. What is the difference between the Enrollment rate (%) of Small states in 2008 and the Enrollment rate (%) of Honduras in 2009?
Offer a terse response. -11.48. What is the difference between the Enrollment rate (%) in Small states in 2008 and the Enrollment rate (%) in Kazakhstan in 2009?
Keep it short and to the point. -14.17. What is the difference between the Enrollment rate (%) in France in 2008 and the Enrollment rate (%) in Honduras in 2009?
Ensure brevity in your answer.  3.54. What is the difference between the Enrollment rate (%) of France in 2008 and the Enrollment rate (%) of Kazakhstan in 2009?
Your answer should be compact. 0.85. What is the difference between the Enrollment rate (%) of Honduras in 2008 and the Enrollment rate (%) of Kazakhstan in 2009?
Ensure brevity in your answer.  -3.07. What is the average Enrollment rate (%) in Small states per year?
Your answer should be compact. 83.59. What is the average Enrollment rate (%) in France per year?
Keep it short and to the point. 98.85. What is the average Enrollment rate (%) of Honduras per year?
Your answer should be compact. 93.04. What is the average Enrollment rate (%) in Kazakhstan per year?
Your response must be concise. 97.92. In the year 2000, what is the difference between the Enrollment rate (%) in Small states and Enrollment rate (%) in France?
Give a very brief answer. -17.25. In the year 2000, what is the difference between the Enrollment rate (%) of Small states and Enrollment rate (%) of Honduras?
Keep it short and to the point. -5.85. In the year 2000, what is the difference between the Enrollment rate (%) of Small states and Enrollment rate (%) of Kazakhstan?
Provide a short and direct response. -12.97. In the year 2000, what is the difference between the Enrollment rate (%) of France and Enrollment rate (%) of Honduras?
Offer a terse response. 11.4. In the year 2000, what is the difference between the Enrollment rate (%) in France and Enrollment rate (%) in Kazakhstan?
Give a very brief answer. 4.28. In the year 2000, what is the difference between the Enrollment rate (%) in Honduras and Enrollment rate (%) in Kazakhstan?
Offer a terse response. -7.11. In the year 2003, what is the difference between the Enrollment rate (%) of Small states and Enrollment rate (%) of France?
Your response must be concise. -14.78. In the year 2003, what is the difference between the Enrollment rate (%) of Small states and Enrollment rate (%) of Honduras?
Provide a succinct answer. -8.97. In the year 2003, what is the difference between the Enrollment rate (%) in Small states and Enrollment rate (%) in Kazakhstan?
Ensure brevity in your answer.  -14.45. In the year 2003, what is the difference between the Enrollment rate (%) of France and Enrollment rate (%) of Honduras?
Provide a succinct answer. 5.81. In the year 2003, what is the difference between the Enrollment rate (%) of France and Enrollment rate (%) of Kazakhstan?
Your answer should be very brief. 0.34. In the year 2003, what is the difference between the Enrollment rate (%) of Honduras and Enrollment rate (%) of Kazakhstan?
Keep it short and to the point. -5.48. In the year 2004, what is the difference between the Enrollment rate (%) of Small states and Enrollment rate (%) of France?
Your answer should be very brief. -14.17. In the year 2004, what is the difference between the Enrollment rate (%) in Small states and Enrollment rate (%) in Honduras?
Ensure brevity in your answer.  -11.02. In the year 2004, what is the difference between the Enrollment rate (%) of Small states and Enrollment rate (%) of Kazakhstan?
Make the answer very short. -14.6. In the year 2004, what is the difference between the Enrollment rate (%) of France and Enrollment rate (%) of Honduras?
Your response must be concise. 3.14. In the year 2004, what is the difference between the Enrollment rate (%) of France and Enrollment rate (%) of Kazakhstan?
Make the answer very short. -0.43. In the year 2004, what is the difference between the Enrollment rate (%) in Honduras and Enrollment rate (%) in Kazakhstan?
Make the answer very short. -3.58. In the year 2005, what is the difference between the Enrollment rate (%) in Small states and Enrollment rate (%) in France?
Ensure brevity in your answer.  -15.83. In the year 2005, what is the difference between the Enrollment rate (%) in Small states and Enrollment rate (%) in Honduras?
Make the answer very short. -7.85. In the year 2005, what is the difference between the Enrollment rate (%) in Small states and Enrollment rate (%) in Kazakhstan?
Provide a succinct answer. -15.05. In the year 2005, what is the difference between the Enrollment rate (%) in France and Enrollment rate (%) in Honduras?
Provide a succinct answer. 7.99. In the year 2005, what is the difference between the Enrollment rate (%) of France and Enrollment rate (%) of Kazakhstan?
Your answer should be compact. 0.78. In the year 2005, what is the difference between the Enrollment rate (%) in Honduras and Enrollment rate (%) in Kazakhstan?
Provide a succinct answer. -7.2. In the year 2006, what is the difference between the Enrollment rate (%) of Small states and Enrollment rate (%) of France?
Your answer should be very brief. -15.16. In the year 2006, what is the difference between the Enrollment rate (%) of Small states and Enrollment rate (%) of Honduras?
Your answer should be compact. -11.41. In the year 2006, what is the difference between the Enrollment rate (%) in Small states and Enrollment rate (%) in Kazakhstan?
Offer a terse response. -14.41. In the year 2006, what is the difference between the Enrollment rate (%) in France and Enrollment rate (%) in Honduras?
Your response must be concise. 3.74. In the year 2006, what is the difference between the Enrollment rate (%) in France and Enrollment rate (%) in Kazakhstan?
Offer a very short reply. 0.75. In the year 2006, what is the difference between the Enrollment rate (%) in Honduras and Enrollment rate (%) in Kazakhstan?
Your response must be concise. -2.99. In the year 2007, what is the difference between the Enrollment rate (%) in Small states and Enrollment rate (%) in France?
Your answer should be compact. -15.36. In the year 2007, what is the difference between the Enrollment rate (%) in Small states and Enrollment rate (%) in Honduras?
Ensure brevity in your answer.  -8.37. In the year 2007, what is the difference between the Enrollment rate (%) of Small states and Enrollment rate (%) of Kazakhstan?
Your answer should be very brief. -14.97. In the year 2007, what is the difference between the Enrollment rate (%) of France and Enrollment rate (%) of Honduras?
Give a very brief answer. 7. In the year 2007, what is the difference between the Enrollment rate (%) of France and Enrollment rate (%) of Kazakhstan?
Make the answer very short. 0.4. In the year 2007, what is the difference between the Enrollment rate (%) of Honduras and Enrollment rate (%) of Kazakhstan?
Your answer should be compact. -6.6. In the year 2008, what is the difference between the Enrollment rate (%) of Small states and Enrollment rate (%) of France?
Provide a succinct answer. -15.02. In the year 2008, what is the difference between the Enrollment rate (%) of Small states and Enrollment rate (%) of Honduras?
Offer a very short reply. -11.1. In the year 2008, what is the difference between the Enrollment rate (%) in Small states and Enrollment rate (%) in Kazakhstan?
Your answer should be very brief. -14.53. In the year 2008, what is the difference between the Enrollment rate (%) in France and Enrollment rate (%) in Honduras?
Provide a short and direct response. 3.92. In the year 2008, what is the difference between the Enrollment rate (%) in France and Enrollment rate (%) in Kazakhstan?
Your response must be concise. 0.49. In the year 2008, what is the difference between the Enrollment rate (%) of Honduras and Enrollment rate (%) of Kazakhstan?
Give a very brief answer. -3.43. In the year 2009, what is the difference between the Enrollment rate (%) in Small states and Enrollment rate (%) in France?
Keep it short and to the point. -14.44. In the year 2009, what is the difference between the Enrollment rate (%) in Small states and Enrollment rate (%) in Honduras?
Your response must be concise. -10.99. In the year 2009, what is the difference between the Enrollment rate (%) in Small states and Enrollment rate (%) in Kazakhstan?
Give a very brief answer. -13.68. In the year 2009, what is the difference between the Enrollment rate (%) in France and Enrollment rate (%) in Honduras?
Give a very brief answer. 3.46. In the year 2009, what is the difference between the Enrollment rate (%) of France and Enrollment rate (%) of Kazakhstan?
Ensure brevity in your answer.  0.77. In the year 2009, what is the difference between the Enrollment rate (%) in Honduras and Enrollment rate (%) in Kazakhstan?
Give a very brief answer. -2.69. What is the ratio of the Enrollment rate (%) in France in 2000 to that in 2003?
Give a very brief answer. 1.01. What is the ratio of the Enrollment rate (%) of Honduras in 2000 to that in 2003?
Ensure brevity in your answer.  0.95. What is the ratio of the Enrollment rate (%) in Kazakhstan in 2000 to that in 2003?
Make the answer very short. 0.97. What is the ratio of the Enrollment rate (%) in Small states in 2000 to that in 2004?
Your answer should be compact. 0.98. What is the ratio of the Enrollment rate (%) in France in 2000 to that in 2004?
Ensure brevity in your answer.  1.02. What is the ratio of the Enrollment rate (%) of Honduras in 2000 to that in 2004?
Ensure brevity in your answer.  0.93. What is the ratio of the Enrollment rate (%) in Kazakhstan in 2000 to that in 2004?
Your answer should be compact. 0.97. What is the ratio of the Enrollment rate (%) in Small states in 2000 to that in 2005?
Make the answer very short. 0.99. What is the ratio of the Enrollment rate (%) in Kazakhstan in 2000 to that in 2005?
Your response must be concise. 0.97. What is the ratio of the Enrollment rate (%) in Small states in 2000 to that in 2006?
Make the answer very short. 0.98. What is the ratio of the Enrollment rate (%) of Honduras in 2000 to that in 2006?
Provide a succinct answer. 0.92. What is the ratio of the Enrollment rate (%) of Kazakhstan in 2000 to that in 2006?
Your answer should be compact. 0.97. What is the ratio of the Enrollment rate (%) in Small states in 2000 to that in 2007?
Your response must be concise. 0.98. What is the ratio of the Enrollment rate (%) of France in 2000 to that in 2007?
Make the answer very short. 1. What is the ratio of the Enrollment rate (%) of Honduras in 2000 to that in 2007?
Give a very brief answer. 0.96. What is the ratio of the Enrollment rate (%) in Kazakhstan in 2000 to that in 2007?
Your response must be concise. 0.96. What is the ratio of the Enrollment rate (%) of Small states in 2000 to that in 2008?
Provide a short and direct response. 0.98. What is the ratio of the Enrollment rate (%) of France in 2000 to that in 2008?
Your answer should be very brief. 1. What is the ratio of the Enrollment rate (%) of Honduras in 2000 to that in 2008?
Make the answer very short. 0.93. What is the ratio of the Enrollment rate (%) of Kazakhstan in 2000 to that in 2008?
Provide a succinct answer. 0.97. What is the ratio of the Enrollment rate (%) of Small states in 2000 to that in 2009?
Your response must be concise. 0.97. What is the ratio of the Enrollment rate (%) of Honduras in 2000 to that in 2009?
Provide a short and direct response. 0.92. What is the ratio of the Enrollment rate (%) of Kazakhstan in 2000 to that in 2009?
Offer a terse response. 0.97. What is the ratio of the Enrollment rate (%) in France in 2003 to that in 2004?
Provide a short and direct response. 1. What is the ratio of the Enrollment rate (%) of Honduras in 2003 to that in 2004?
Make the answer very short. 0.98. What is the ratio of the Enrollment rate (%) in Kazakhstan in 2003 to that in 2004?
Provide a succinct answer. 1. What is the ratio of the Enrollment rate (%) of France in 2003 to that in 2005?
Your answer should be very brief. 0.99. What is the ratio of the Enrollment rate (%) of Honduras in 2003 to that in 2005?
Your response must be concise. 1.01. What is the ratio of the Enrollment rate (%) in Honduras in 2003 to that in 2006?
Your answer should be very brief. 0.97. What is the ratio of the Enrollment rate (%) in Small states in 2003 to that in 2007?
Make the answer very short. 1. What is the ratio of the Enrollment rate (%) of France in 2003 to that in 2007?
Provide a short and direct response. 0.99. What is the ratio of the Enrollment rate (%) of Kazakhstan in 2003 to that in 2007?
Provide a succinct answer. 0.99. What is the ratio of the Enrollment rate (%) in Small states in 2003 to that in 2008?
Give a very brief answer. 0.99. What is the ratio of the Enrollment rate (%) in France in 2003 to that in 2008?
Offer a very short reply. 0.99. What is the ratio of the Enrollment rate (%) of Honduras in 2003 to that in 2008?
Provide a succinct answer. 0.97. What is the ratio of the Enrollment rate (%) of Small states in 2003 to that in 2009?
Make the answer very short. 0.99. What is the ratio of the Enrollment rate (%) in France in 2003 to that in 2009?
Make the answer very short. 0.99. What is the ratio of the Enrollment rate (%) of Honduras in 2003 to that in 2009?
Provide a succinct answer. 0.97. What is the ratio of the Enrollment rate (%) of France in 2004 to that in 2005?
Give a very brief answer. 0.99. What is the ratio of the Enrollment rate (%) of Honduras in 2004 to that in 2005?
Keep it short and to the point. 1.04. What is the ratio of the Enrollment rate (%) in Kazakhstan in 2004 to that in 2005?
Provide a succinct answer. 1. What is the ratio of the Enrollment rate (%) in France in 2004 to that in 2006?
Give a very brief answer. 0.99. What is the ratio of the Enrollment rate (%) in Small states in 2004 to that in 2007?
Your response must be concise. 1. What is the ratio of the Enrollment rate (%) in France in 2004 to that in 2007?
Keep it short and to the point. 0.99. What is the ratio of the Enrollment rate (%) of Honduras in 2004 to that in 2007?
Your answer should be very brief. 1.03. What is the ratio of the Enrollment rate (%) of Kazakhstan in 2004 to that in 2007?
Make the answer very short. 0.99. What is the ratio of the Enrollment rate (%) of France in 2004 to that in 2008?
Make the answer very short. 0.99. What is the ratio of the Enrollment rate (%) of Honduras in 2004 to that in 2008?
Offer a very short reply. 0.99. What is the ratio of the Enrollment rate (%) in France in 2004 to that in 2009?
Keep it short and to the point. 0.99. What is the ratio of the Enrollment rate (%) of Kazakhstan in 2004 to that in 2009?
Provide a succinct answer. 1. What is the ratio of the Enrollment rate (%) in Honduras in 2005 to that in 2006?
Your answer should be very brief. 0.95. What is the ratio of the Enrollment rate (%) in Small states in 2005 to that in 2007?
Keep it short and to the point. 0.99. What is the ratio of the Enrollment rate (%) in France in 2005 to that in 2007?
Offer a terse response. 1. What is the ratio of the Enrollment rate (%) of Honduras in 2005 to that in 2007?
Make the answer very short. 0.99. What is the ratio of the Enrollment rate (%) of Small states in 2005 to that in 2008?
Your answer should be compact. 0.99. What is the ratio of the Enrollment rate (%) in Honduras in 2005 to that in 2008?
Offer a very short reply. 0.96. What is the ratio of the Enrollment rate (%) of Kazakhstan in 2005 to that in 2008?
Provide a succinct answer. 1. What is the ratio of the Enrollment rate (%) in Small states in 2005 to that in 2009?
Your answer should be very brief. 0.98. What is the ratio of the Enrollment rate (%) of Honduras in 2005 to that in 2009?
Ensure brevity in your answer.  0.95. What is the ratio of the Enrollment rate (%) of Small states in 2006 to that in 2007?
Your answer should be very brief. 1. What is the ratio of the Enrollment rate (%) of France in 2006 to that in 2007?
Provide a short and direct response. 1. What is the ratio of the Enrollment rate (%) of Honduras in 2006 to that in 2007?
Your answer should be very brief. 1.03. What is the ratio of the Enrollment rate (%) in Kazakhstan in 2006 to that in 2007?
Give a very brief answer. 1. What is the ratio of the Enrollment rate (%) in Small states in 2006 to that in 2009?
Offer a terse response. 0.99. What is the ratio of the Enrollment rate (%) of France in 2006 to that in 2009?
Make the answer very short. 1. What is the ratio of the Enrollment rate (%) of Honduras in 2006 to that in 2009?
Offer a very short reply. 1. What is the ratio of the Enrollment rate (%) of Kazakhstan in 2006 to that in 2009?
Provide a short and direct response. 1. What is the ratio of the Enrollment rate (%) in Small states in 2007 to that in 2008?
Your answer should be compact. 1. What is the ratio of the Enrollment rate (%) of Honduras in 2007 to that in 2008?
Offer a very short reply. 0.97. What is the ratio of the Enrollment rate (%) of Kazakhstan in 2007 to that in 2008?
Give a very brief answer. 1. What is the ratio of the Enrollment rate (%) of Honduras in 2007 to that in 2009?
Your answer should be compact. 0.96. What is the ratio of the Enrollment rate (%) of Kazakhstan in 2007 to that in 2009?
Provide a succinct answer. 1.01. What is the ratio of the Enrollment rate (%) in Small states in 2008 to that in 2009?
Keep it short and to the point. 0.99. What is the ratio of the Enrollment rate (%) in Honduras in 2008 to that in 2009?
Ensure brevity in your answer.  1. What is the ratio of the Enrollment rate (%) of Kazakhstan in 2008 to that in 2009?
Offer a terse response. 1. What is the difference between the highest and the second highest Enrollment rate (%) of Small states?
Keep it short and to the point. 0.49. What is the difference between the highest and the second highest Enrollment rate (%) of France?
Keep it short and to the point. 0.31. What is the difference between the highest and the second highest Enrollment rate (%) of Honduras?
Offer a very short reply. 0.15. What is the difference between the highest and the second highest Enrollment rate (%) of Kazakhstan?
Provide a succinct answer. 0.19. What is the difference between the highest and the lowest Enrollment rate (%) in Small states?
Ensure brevity in your answer.  2.32. What is the difference between the highest and the lowest Enrollment rate (%) of France?
Ensure brevity in your answer.  1.69. What is the difference between the highest and the lowest Enrollment rate (%) of Honduras?
Offer a very short reply. 7.45. What is the difference between the highest and the lowest Enrollment rate (%) in Kazakhstan?
Provide a short and direct response. 3.57. 